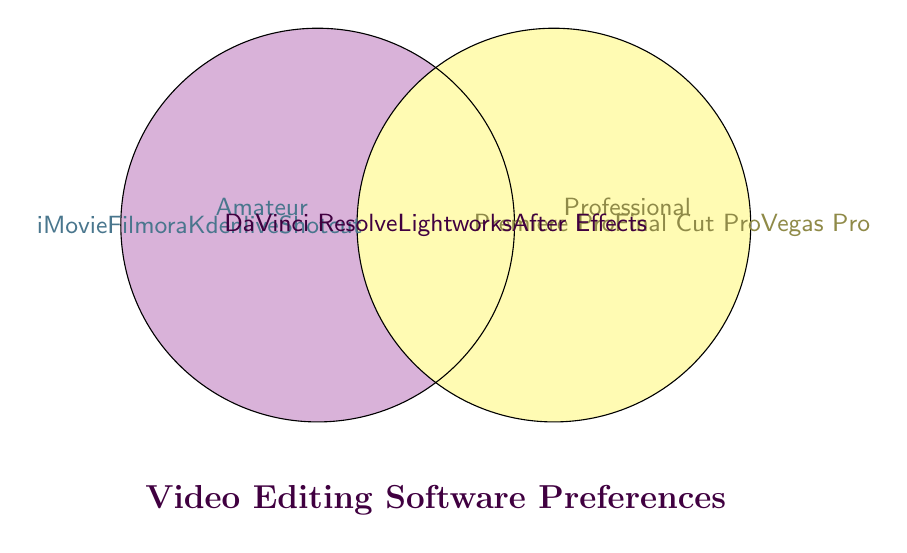What is the title of the Venn diagram? The title is typically located somewhere prominently to describe the contents or purpose of the figure. Here it is shown under the circles.
Answer: Video Editing Software Preferences Which software is used exclusively by amateur editors? The software names are listed in the left circle that is not intersecting the right circle. The names are separated by line breaks.
Answer: iMovie, Filmora, Kdenlive, Shotcut Which software do professional editors prefer? The software names are listed in the right circle that is not intersecting the left circle. The names are separated by line breaks.
Answer: Premiere Pro, Final Cut Pro, Vegas Pro Which software is used by both amateur and professional editors? Look at the intersection of both circles where software used by both types of editors is displayed.
Answer: DaVinci Resolve, Lightworks, After Effects How many software options do amateur-only editors prefer? Count the number of software listed in the left circle, not in the intersection with the right circle.
Answer: 4 How many software options do professional-only editors prefer? Count the number of software listed in the right circle, not in the intersection with the left circle.
Answer: 3 How many software options are preferred by both amateur and professional editors combined? Count the number of software in the intersection area where both circles overlap.
Answer: 3 Which has more software options, amateur or professional editors? Compare the count of software options listed exclusively for amateur editors and those for professional editors.
Answer: Amateur editors Name a software that is not preferred by amateur editors. This software will not appear in the left circle either individually or in the intersection.
Answer: Premiere Pro, Final Cut Pro, Vegas Pro, Lightworks, DaVinci Resolve, After Effects Which group has fewer unique software options, amateurs or professionals? Compare the number of unique software options listed for amateur editors vs. professional editors.
Answer: Professional editors 